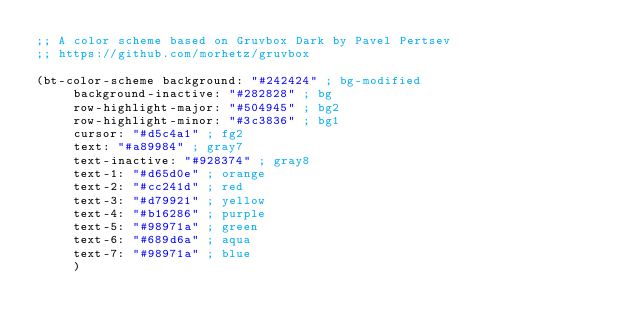<code> <loc_0><loc_0><loc_500><loc_500><_Scheme_>;; A color scheme based on Gruvbox Dark by Pavel Pertsev
;; https://github.com/morhetz/gruvbox

(bt-color-scheme background: "#242424" ; bg-modified
		 background-inactive: "#282828" ; bg
		 row-highlight-major: "#504945" ; bg2
		 row-highlight-minor: "#3c3836" ; bg1
		 cursor: "#d5c4a1" ; fg2
		 text: "#a89984" ; gray7
		 text-inactive: "#928374" ; gray8
		 text-1: "#d65d0e" ; orange
		 text-2: "#cc241d" ; red
		 text-3: "#d79921" ; yellow
		 text-4: "#b16286" ; purple
		 text-5: "#98971a" ; green
		 text-6: "#689d6a" ; aqua
		 text-7: "#98971a" ; blue
		 )
</code> 